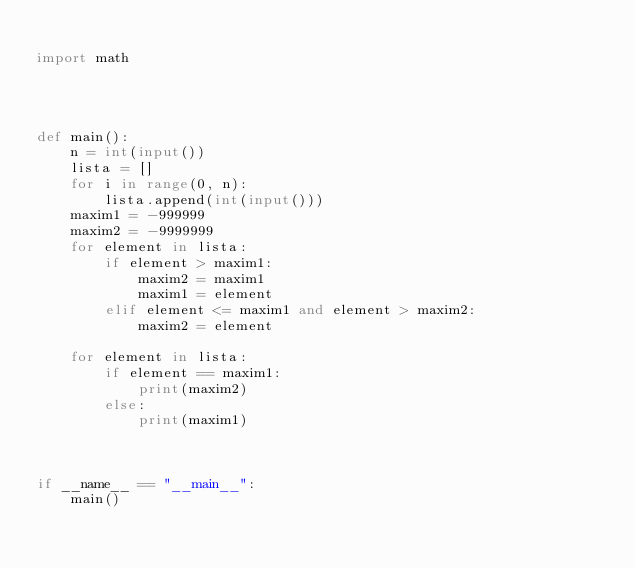Convert code to text. <code><loc_0><loc_0><loc_500><loc_500><_Python_>
import math




def main():
    n = int(input())
    lista = []
    for i in range(0, n):
        lista.append(int(input()))
    maxim1 = -999999
    maxim2 = -9999999
    for element in lista:
        if element > maxim1:
            maxim2 = maxim1
            maxim1 = element
        elif element <= maxim1 and element > maxim2:
            maxim2 = element
    
    for element in lista:
        if element == maxim1:
            print(maxim2)
        else:
            print(maxim1)



if __name__ == "__main__":
    main()</code> 